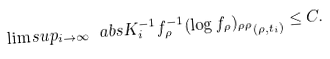Convert formula to latex. <formula><loc_0><loc_0><loc_500><loc_500>\lim s u p _ { i \to \infty } \ a b s { K _ { i } ^ { - 1 } f ^ { - 1 } _ { \rho } ( \log f _ { \rho } ) _ { \rho \rho } } _ { ( \rho , t _ { i } ) } \leq C .</formula> 